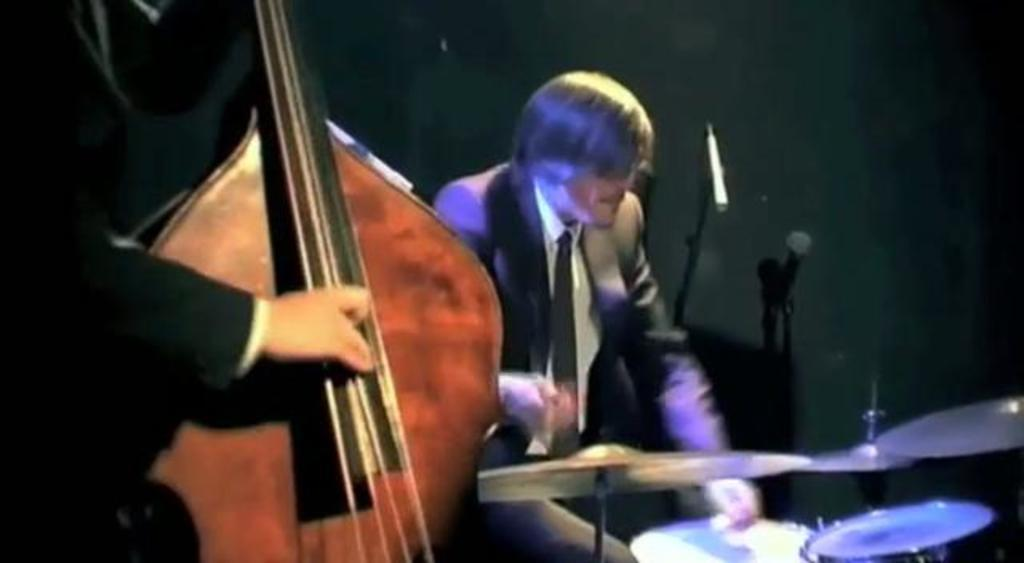Who or what is present in the image? There are people in the image. What objects are associated with the people in the image? There are musical instruments and a microphone in the image. How many cats can be seen in the image? There are no cats present in the image. 